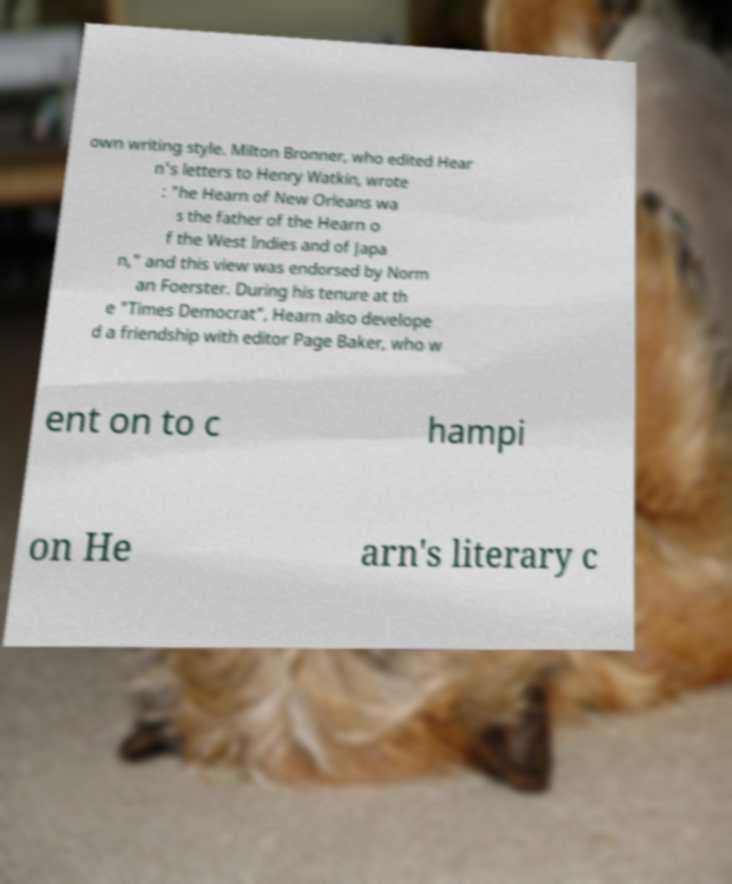Please identify and transcribe the text found in this image. own writing style. Milton Bronner, who edited Hear n's letters to Henry Watkin, wrote : "he Hearn of New Orleans wa s the father of the Hearn o f the West Indies and of Japa n," and this view was endorsed by Norm an Foerster. During his tenure at th e "Times Democrat", Hearn also develope d a friendship with editor Page Baker, who w ent on to c hampi on He arn's literary c 